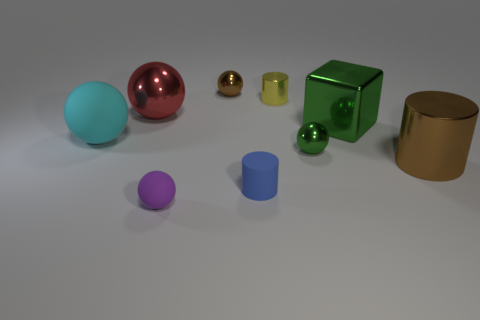Subtract all large rubber spheres. How many spheres are left? 4 Subtract all red spheres. How many spheres are left? 4 Subtract all yellow balls. Subtract all cyan cubes. How many balls are left? 5 Add 1 small rubber spheres. How many objects exist? 10 Subtract all balls. How many objects are left? 4 Add 1 large brown metallic things. How many large brown metallic things exist? 2 Subtract 1 green spheres. How many objects are left? 8 Subtract all cyan balls. Subtract all tiny yellow cylinders. How many objects are left? 7 Add 3 yellow objects. How many yellow objects are left? 4 